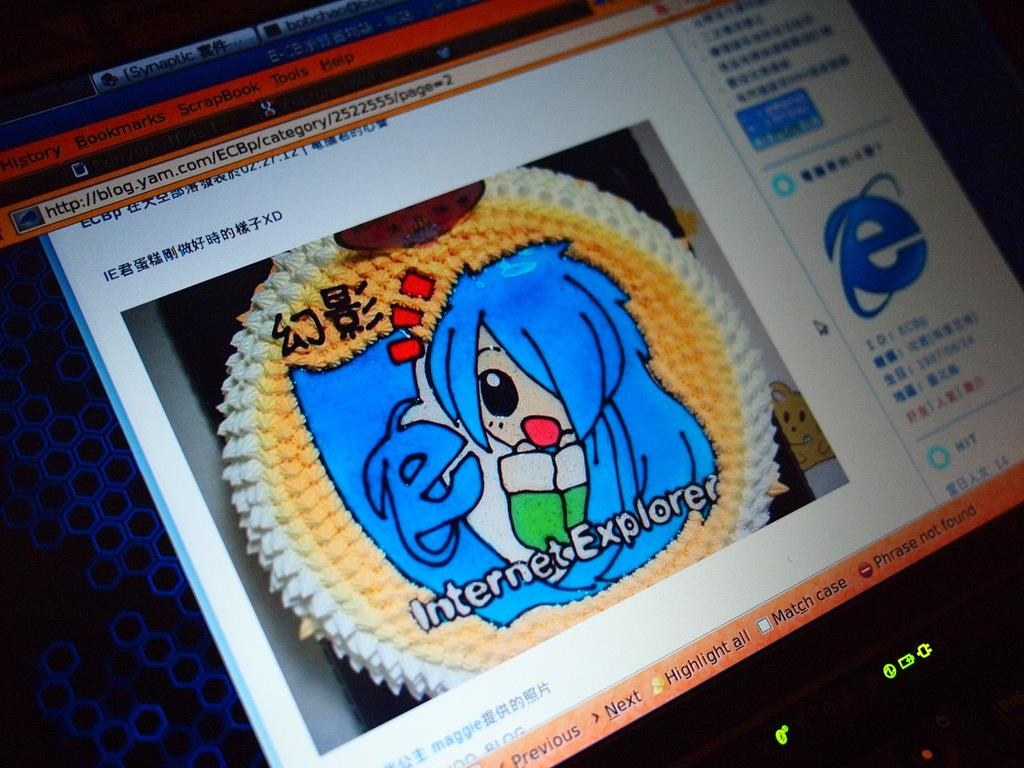What is the main subject of the image? The main subject of the image is a laptop screen. Can you describe what is displayed on the laptop screen? Unfortunately, the image only shows the laptop screen itself, and we cannot see the content displayed on it. What direction are the dolls facing on the laptop screen? There are no dolls present on the laptop screen, as the image only shows the laptop screen itself and does not display any content. 